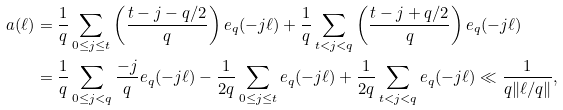Convert formula to latex. <formula><loc_0><loc_0><loc_500><loc_500>a ( \ell ) & = \frac { 1 } { q } \sum _ { 0 \leq j \leq t } \left ( \frac { t - j - q / 2 } { q } \right ) e _ { q } ( - j \ell ) + \frac { 1 } { q } \sum _ { t < j < q } \left ( \frac { t - j + q / 2 } { q } \right ) e _ { q } ( - j \ell ) \\ & = \frac { 1 } { q } \sum _ { 0 \leq j < q } \frac { - j } { q } e _ { q } ( - j \ell ) - \frac { 1 } { 2 q } \sum _ { 0 \leq j \leq t } e _ { q } ( - j \ell ) + \frac { 1 } { 2 q } \sum _ { t < j < q } e _ { q } ( - j \ell ) \ll \frac { 1 } { q \| \ell / q \| } ,</formula> 